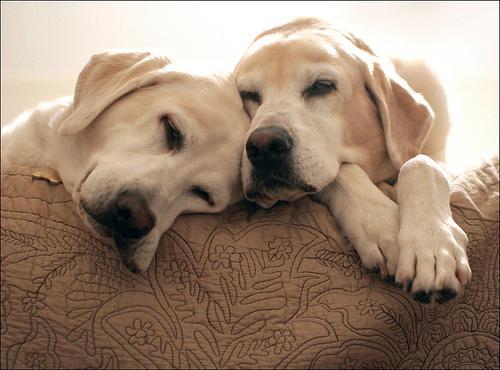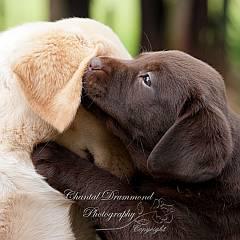The first image is the image on the left, the second image is the image on the right. Evaluate the accuracy of this statement regarding the images: "There are three dogs in one picture and two in the other picture.". Is it true? Answer yes or no. No. The first image is the image on the left, the second image is the image on the right. Analyze the images presented: Is the assertion "There are a total of 2 adult Labradors interacting with each other." valid? Answer yes or no. Yes. 